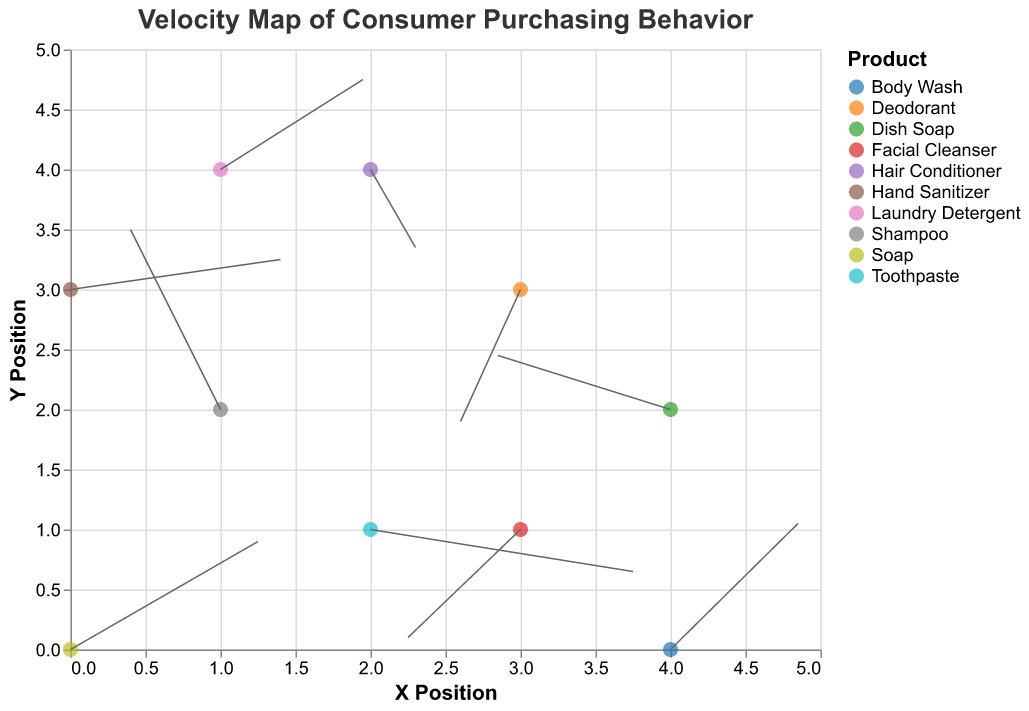What is the title of the plot? The title is prominently displayed at the top of the plot, stating the overall theme or subject of the figure.
Answer: Velocity Map of Consumer Purchasing Behavior How many unique products are displayed in the plot? Each product is represented as a colored point, with a legend indicating the names. By counting the unique names in the legend, we find there are 10 products.
Answer: 10 Which product shows the highest positive x-direction movement? Observing the lengths and directions of the arrows, the product with the largest positive x-direction movement is Toothpaste with u = 3.5.
Answer: Toothpaste What are the coordinates of the Hand Sanitizer data point? By looking at the plot and the corresponding legend/tooltip, the coordinates for Hand Sanitizer are X = 0 and Y = 3.
Answer: (0, 3) Which product shows the most negative y-direction movement? By identifying the arrow with the largest negative y-component, Deodorant has the most negative y-direction movement with v = -2.2.
Answer: Deodorant How many products show positive movement in both x and y directions? By counting the arrows with both x and y components positive, Soap (2.5, 1.8), Laundry Detergent (1.9, 1.5), and Body Wash (1.7, 2.1) meet this criteria.
Answer: 3 For the product Hair Conditioner, what is the resultant velocity from its u and v components? Calculate the resultant velocity using the formula √(u²+v²), for u = 0.6 and v = -1.3, √(0.6² + (-1.3)²) = √(0.36 + 1.69) = √2.05 ≈ 1.43.
Answer: 1.43 Which products are moving towards the origin (0,0)? Products moving toward the origin will have negative direction components pointing closer to (0,0). Deodorant (-0.8, -2.2) and Facial Cleanser (-1.5, -1.8) are moving in this direction.
Answer: Deodorant and Facial Cleanser What is the average x-position of all products? Sum all x coordinates (0+1+2+3+1+4+2+4+3+0) = 20, then divide by the number of products (10). The average is 20/10 = 2.
Answer: 2 Which product shows the least movement in the x-direction? By comparing all x-direction components, Hair Conditioner has the smallest u = 0.6.
Answer: Hair Conditioner 